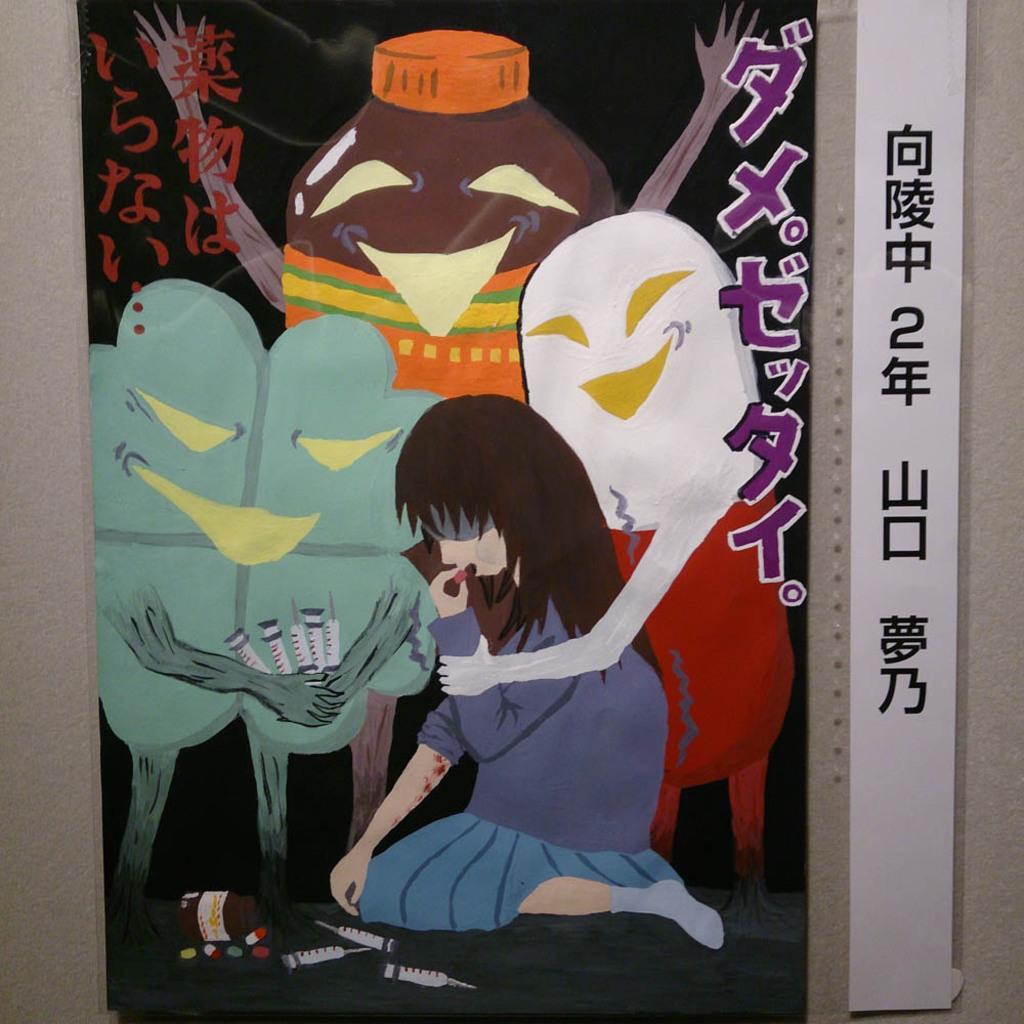Could you give a brief overview of what you see in this image? In this picture we can see a poster on the surface. 